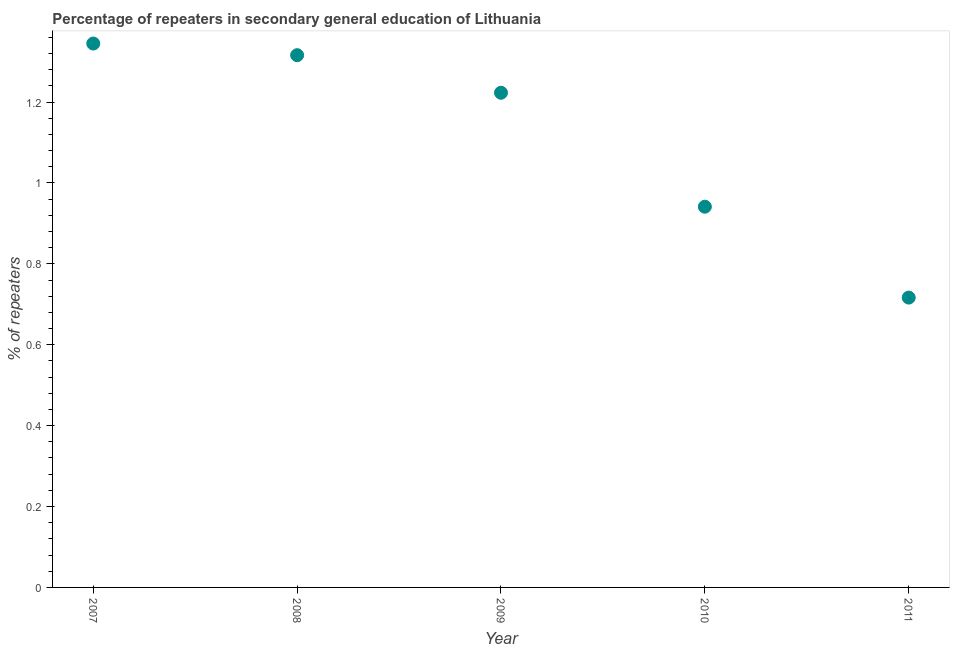What is the percentage of repeaters in 2007?
Your answer should be compact. 1.34. Across all years, what is the maximum percentage of repeaters?
Offer a terse response. 1.34. Across all years, what is the minimum percentage of repeaters?
Your answer should be very brief. 0.72. In which year was the percentage of repeaters maximum?
Your answer should be very brief. 2007. What is the sum of the percentage of repeaters?
Keep it short and to the point. 5.54. What is the difference between the percentage of repeaters in 2009 and 2010?
Your response must be concise. 0.28. What is the average percentage of repeaters per year?
Give a very brief answer. 1.11. What is the median percentage of repeaters?
Ensure brevity in your answer.  1.22. In how many years, is the percentage of repeaters greater than 0.2 %?
Keep it short and to the point. 5. What is the ratio of the percentage of repeaters in 2007 to that in 2009?
Provide a short and direct response. 1.1. Is the percentage of repeaters in 2009 less than that in 2010?
Your response must be concise. No. What is the difference between the highest and the second highest percentage of repeaters?
Your answer should be compact. 0.03. Is the sum of the percentage of repeaters in 2010 and 2011 greater than the maximum percentage of repeaters across all years?
Offer a terse response. Yes. What is the difference between the highest and the lowest percentage of repeaters?
Ensure brevity in your answer.  0.63. Does the percentage of repeaters monotonically increase over the years?
Ensure brevity in your answer.  No. How many dotlines are there?
Offer a very short reply. 1. What is the title of the graph?
Keep it short and to the point. Percentage of repeaters in secondary general education of Lithuania. What is the label or title of the Y-axis?
Your answer should be very brief. % of repeaters. What is the % of repeaters in 2007?
Keep it short and to the point. 1.34. What is the % of repeaters in 2008?
Your response must be concise. 1.32. What is the % of repeaters in 2009?
Ensure brevity in your answer.  1.22. What is the % of repeaters in 2010?
Provide a succinct answer. 0.94. What is the % of repeaters in 2011?
Offer a terse response. 0.72. What is the difference between the % of repeaters in 2007 and 2008?
Your response must be concise. 0.03. What is the difference between the % of repeaters in 2007 and 2009?
Ensure brevity in your answer.  0.12. What is the difference between the % of repeaters in 2007 and 2010?
Keep it short and to the point. 0.4. What is the difference between the % of repeaters in 2007 and 2011?
Keep it short and to the point. 0.63. What is the difference between the % of repeaters in 2008 and 2009?
Your answer should be very brief. 0.09. What is the difference between the % of repeaters in 2008 and 2010?
Make the answer very short. 0.37. What is the difference between the % of repeaters in 2008 and 2011?
Make the answer very short. 0.6. What is the difference between the % of repeaters in 2009 and 2010?
Provide a succinct answer. 0.28. What is the difference between the % of repeaters in 2009 and 2011?
Your answer should be very brief. 0.51. What is the difference between the % of repeaters in 2010 and 2011?
Provide a succinct answer. 0.22. What is the ratio of the % of repeaters in 2007 to that in 2008?
Offer a very short reply. 1.02. What is the ratio of the % of repeaters in 2007 to that in 2010?
Keep it short and to the point. 1.43. What is the ratio of the % of repeaters in 2007 to that in 2011?
Keep it short and to the point. 1.88. What is the ratio of the % of repeaters in 2008 to that in 2009?
Offer a terse response. 1.08. What is the ratio of the % of repeaters in 2008 to that in 2010?
Provide a short and direct response. 1.4. What is the ratio of the % of repeaters in 2008 to that in 2011?
Make the answer very short. 1.84. What is the ratio of the % of repeaters in 2009 to that in 2010?
Ensure brevity in your answer.  1.3. What is the ratio of the % of repeaters in 2009 to that in 2011?
Make the answer very short. 1.71. What is the ratio of the % of repeaters in 2010 to that in 2011?
Provide a short and direct response. 1.31. 